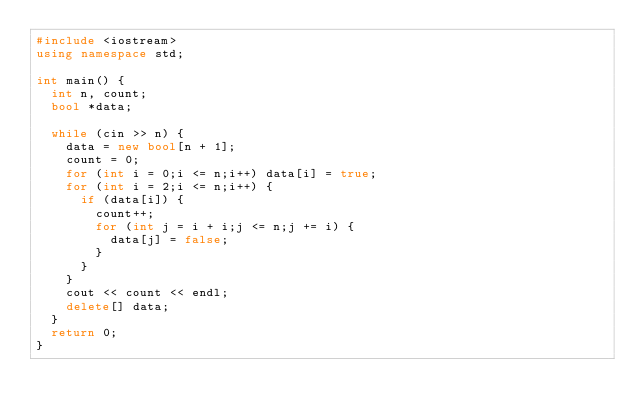<code> <loc_0><loc_0><loc_500><loc_500><_C++_>#include <iostream>
using namespace std;

int main() {
	int n, count;
	bool *data;

	while (cin >> n) {
		data = new bool[n + 1];
		count = 0;
		for (int i = 0;i <= n;i++) data[i] = true;
		for (int i = 2;i <= n;i++) {
			if (data[i]) {
				count++;
				for (int j = i + i;j <= n;j += i) {
					data[j] = false;
				}
			}
		}
		cout << count << endl;
		delete[] data;
	}
	return 0;
}</code> 